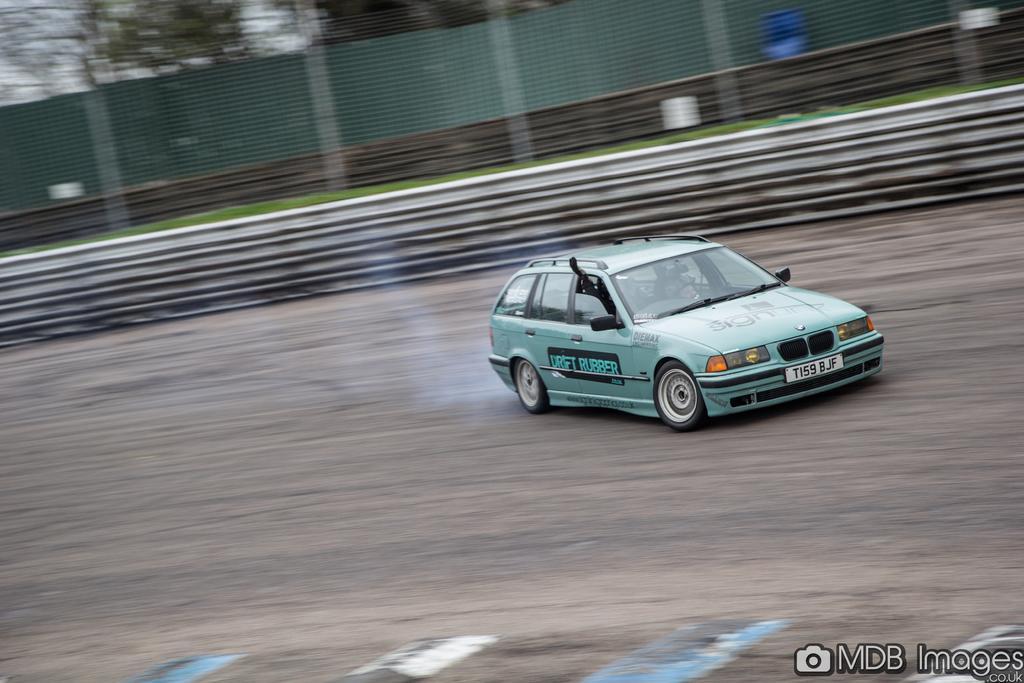How would you summarize this image in a sentence or two? On the right side of the image a car is there. In car some persons are sitting. In the background of the image we can see stairs, grass, mesh, boards, are present. At the bottom of the image ground and some text are there. At the top of the image trees, sky are there. 